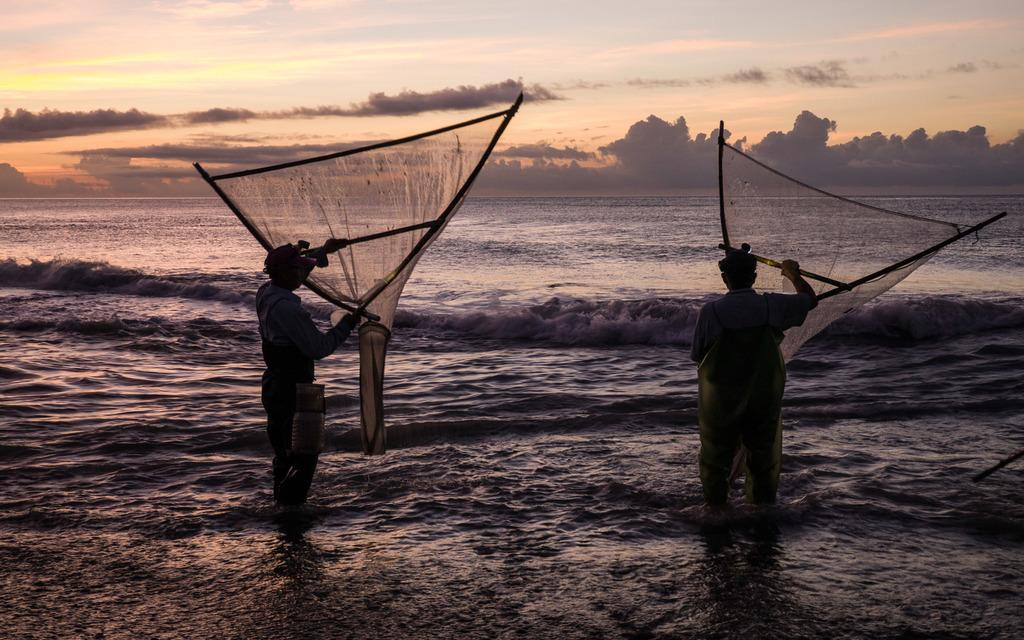How many people are in the image? There are two persons in the image. What are the persons doing in the image? The persons are standing in the water and holding fishing nets. What can be seen in the background of the image? There is sky visible in the background of the image. What is the condition of the sky in the image? Clouds are present in the sky. What is the distance between the two persons in the image? The provided facts do not give information about the distance between the two persons, so it cannot be determined from the image. 